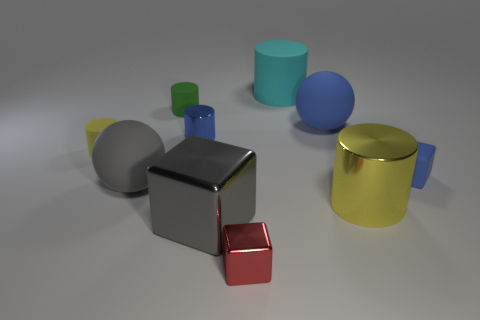Subtract 1 cylinders. How many cylinders are left? 4 Subtract all brown cylinders. Subtract all green spheres. How many cylinders are left? 5 Subtract all balls. How many objects are left? 8 Subtract 0 purple cubes. How many objects are left? 10 Subtract all yellow balls. Subtract all small blue metal cylinders. How many objects are left? 9 Add 4 large blue balls. How many large blue balls are left? 5 Add 4 metal cubes. How many metal cubes exist? 6 